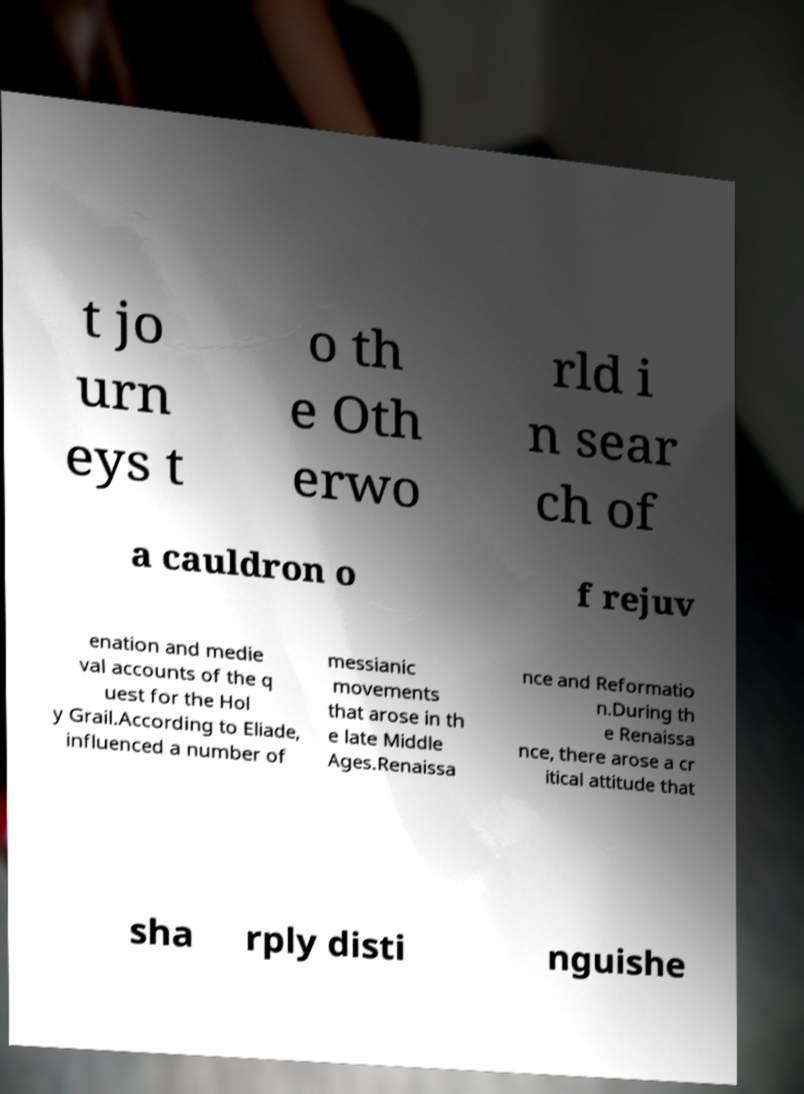What messages or text are displayed in this image? I need them in a readable, typed format. t jo urn eys t o th e Oth erwo rld i n sear ch of a cauldron o f rejuv enation and medie val accounts of the q uest for the Hol y Grail.According to Eliade, influenced a number of messianic movements that arose in th e late Middle Ages.Renaissa nce and Reformatio n.During th e Renaissa nce, there arose a cr itical attitude that sha rply disti nguishe 